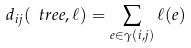<formula> <loc_0><loc_0><loc_500><loc_500>d _ { i j } ( \ t r e e , \ell ) = \sum _ { e \in \gamma ( i , j ) } \ell ( e ) \\</formula> 